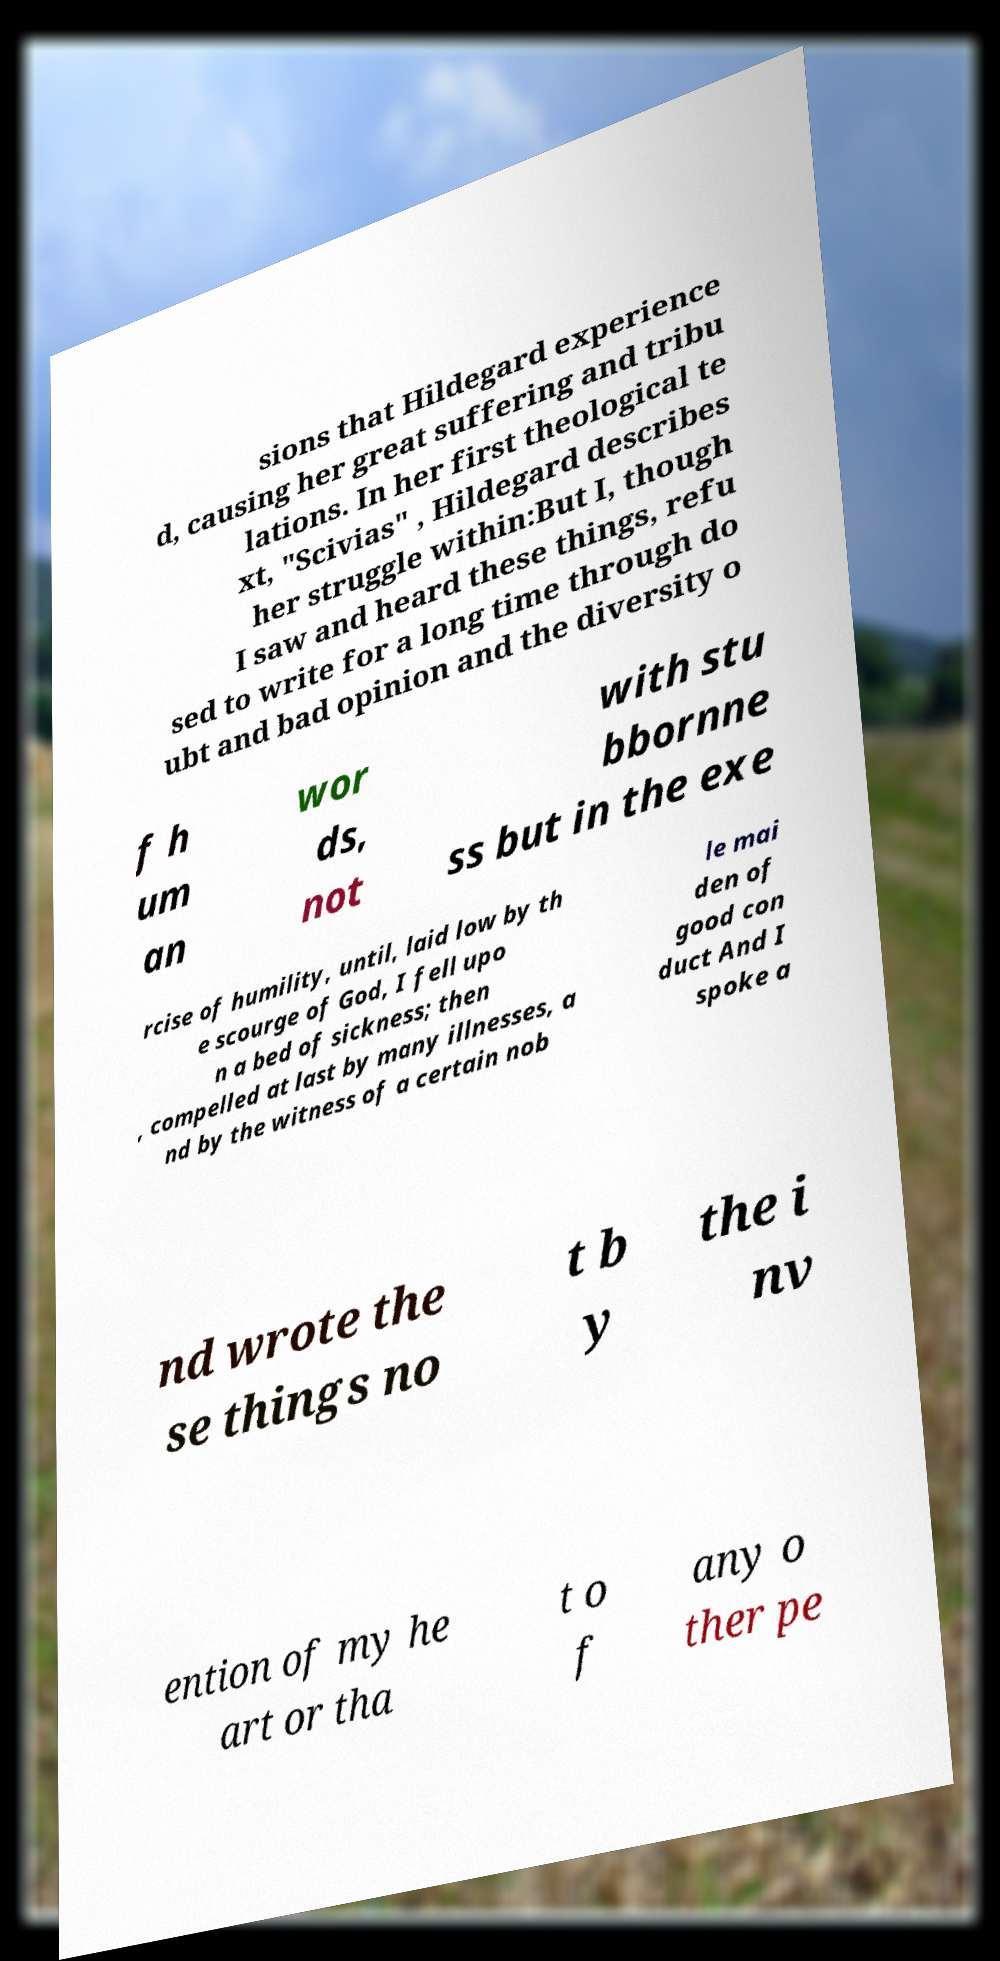Can you accurately transcribe the text from the provided image for me? sions that Hildegard experience d, causing her great suffering and tribu lations. In her first theological te xt, "Scivias" , Hildegard describes her struggle within:But I, though I saw and heard these things, refu sed to write for a long time through do ubt and bad opinion and the diversity o f h um an wor ds, not with stu bbornne ss but in the exe rcise of humility, until, laid low by th e scourge of God, I fell upo n a bed of sickness; then , compelled at last by many illnesses, a nd by the witness of a certain nob le mai den of good con duct And I spoke a nd wrote the se things no t b y the i nv ention of my he art or tha t o f any o ther pe 